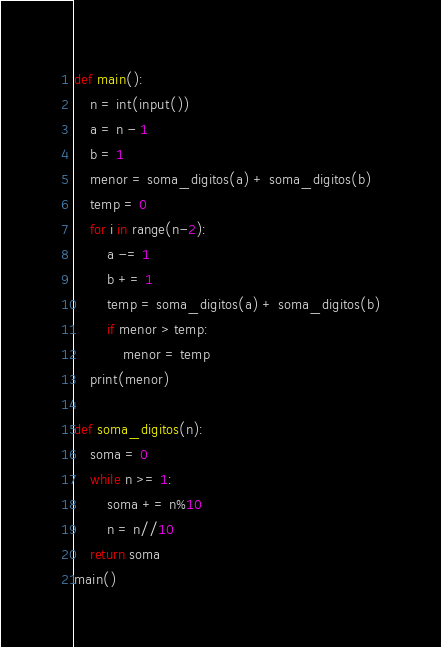Convert code to text. <code><loc_0><loc_0><loc_500><loc_500><_Python_>def main():
    n = int(input())
    a = n - 1
    b = 1
    menor = soma_digitos(a) + soma_digitos(b)
    temp = 0
    for i in range(n-2):
        a -= 1
        b += 1
        temp = soma_digitos(a) + soma_digitos(b)
        if menor > temp:
            menor = temp
    print(menor)

def soma_digitos(n):
    soma = 0
    while n >= 1:
        soma += n%10
        n = n//10
    return soma
main()</code> 